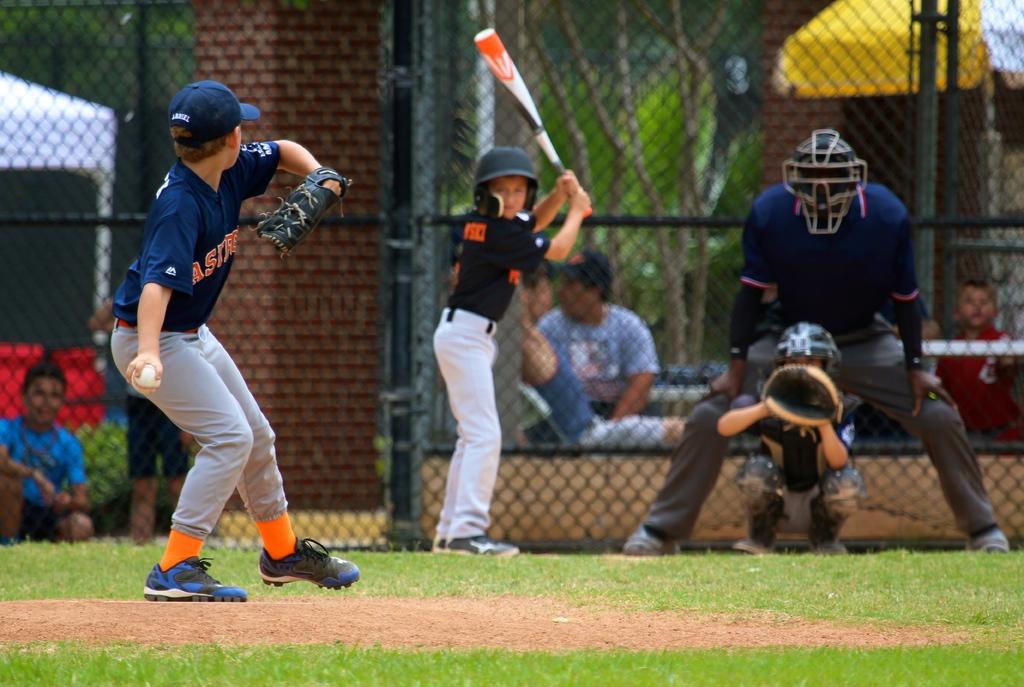What is the first letter on the pitchers shirt?
Your answer should be compact. A. 